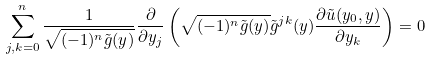Convert formula to latex. <formula><loc_0><loc_0><loc_500><loc_500>\sum _ { j , k = 0 } ^ { n } \frac { 1 } { \sqrt { ( - 1 ) ^ { n } \tilde { g } ( y ) } } \frac { \partial } { \partial y _ { j } } \left ( \sqrt { ( - 1 ) ^ { n } \tilde { g } ( y ) } \tilde { g } ^ { j k } ( y ) \frac { \partial \tilde { u } ( y _ { 0 } , y ) } { \partial y _ { k } } \right ) = 0</formula> 